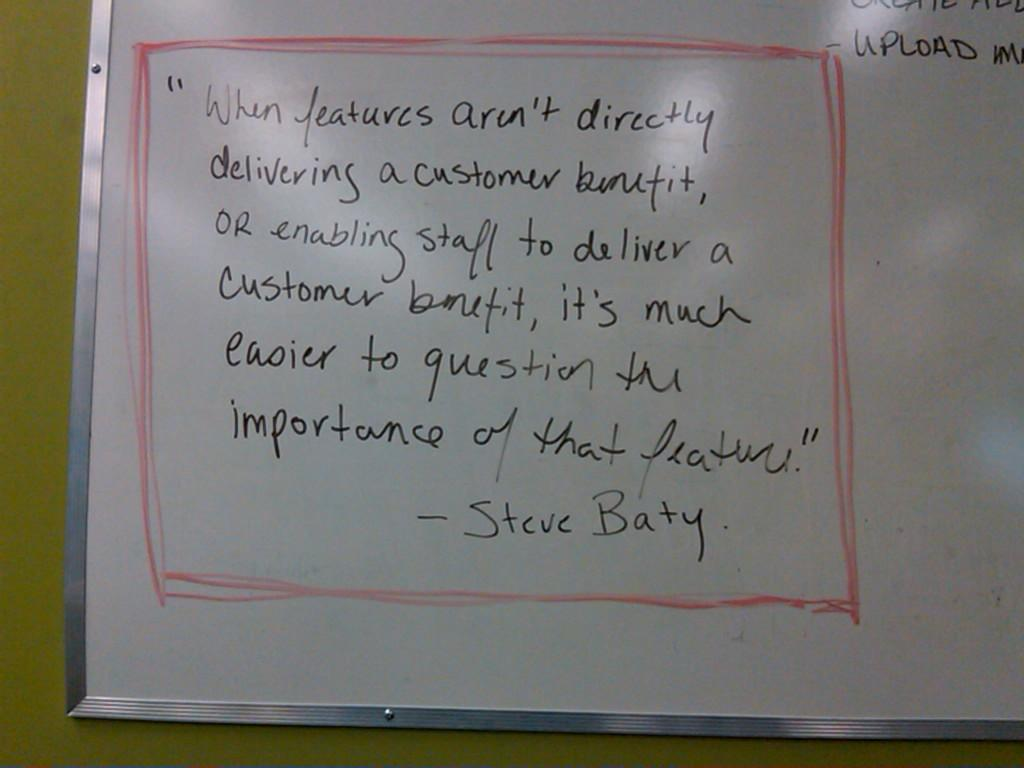<image>
Relay a brief, clear account of the picture shown. There's a quote in black marker on the white board that is bordered in red by Steve Baty. 